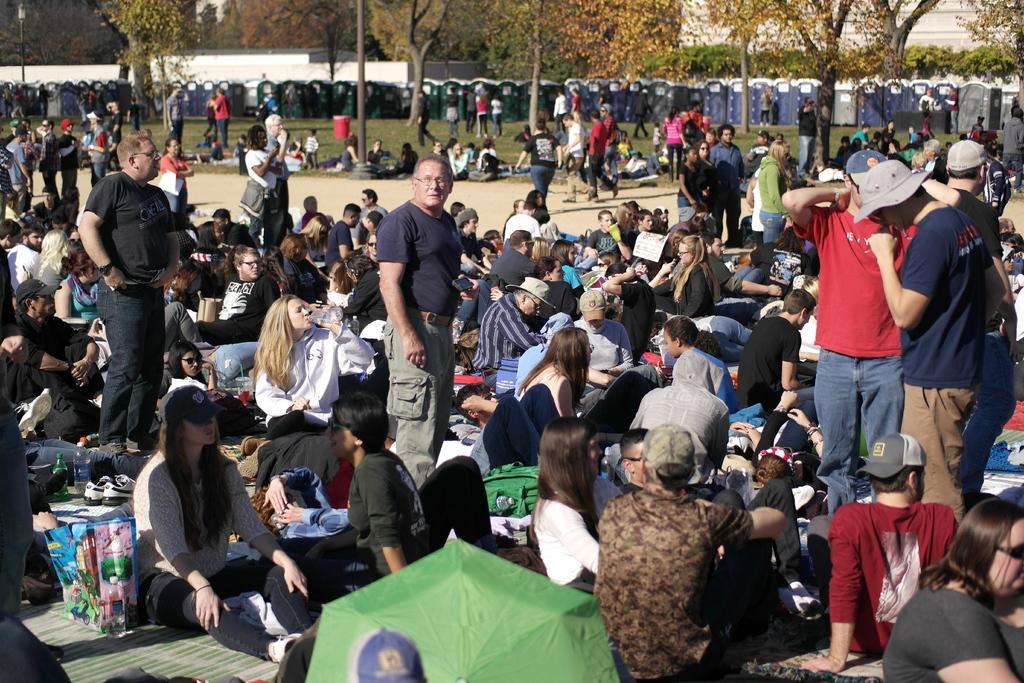Please provide a concise description of this image. This picture is clicked outside. In the foreground we can see the group of people sitting on the ground and there are some items placed on the ground and we can see the group of people standing on the ground. In the background we can see the sky, trees, some objects and group of persons. 